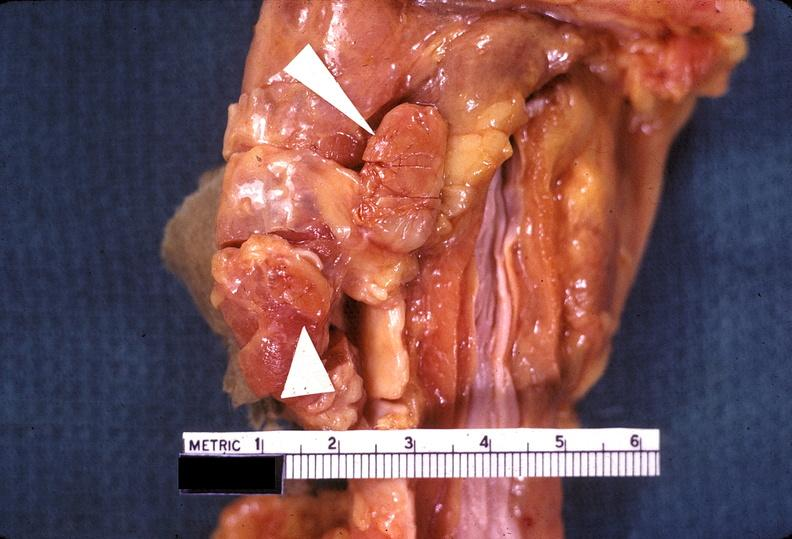what is present?
Answer the question using a single word or phrase. Endocrine 